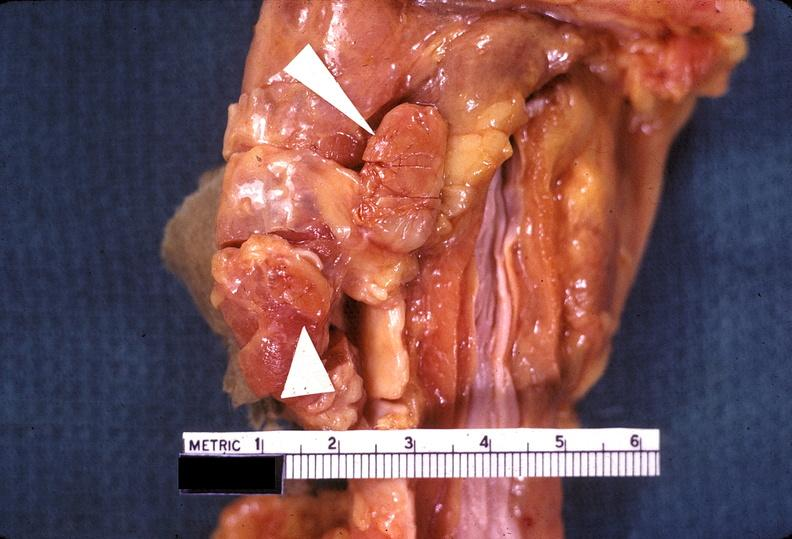what is present?
Answer the question using a single word or phrase. Endocrine 